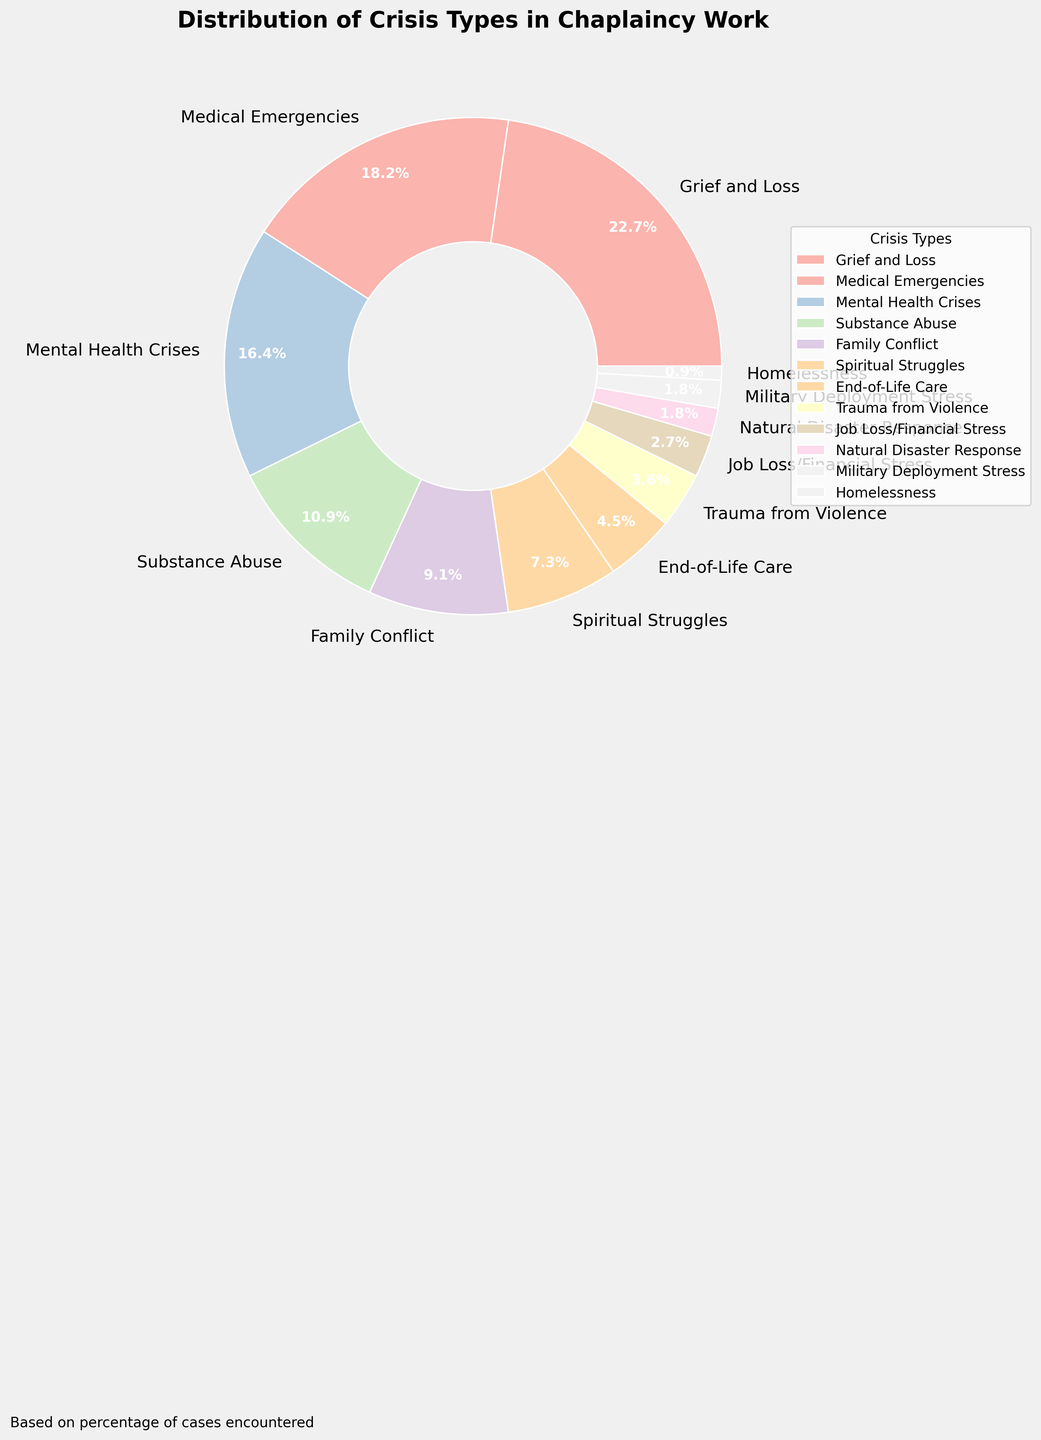What crisis type accounts for the highest percentage? The largest slice in the pie chart represents "Grief and Loss," which accounts for 25% of the total cases.
Answer: Grief and Loss Which crisis type has a lower percentage: "Family Conflict" or "Substance Abuse"? By observing the chart, "Family Conflict" accounts for 10%, while "Substance Abuse" accounts for 12%. Therefore, "Family Conflict" has a lower percentage.
Answer: Family Conflict How do the percentages of "End-of-Life Care" and "Trauma from Violence" combined compare to the percentage of "Mental Health Crises"? "End-of-Life Care" is 5% and "Trauma from Violence" is 4%. Their combined total is 5% + 4% = 9%, which is lower than the 18% of "Mental Health Crises."
Answer: Lower Which crisis type comprises 8% of the cases? The pie chart shows that "Spiritual Struggles" makes up 8% of the cases encountered in chaplaincy work.
Answer: Spiritual Struggles If you combine the percentages of "Job Loss/Financial Stress," "Natural Disaster Response," and "Military Deployment Stress," what is the total percentage? "Job Loss/Financial Stress" is 3%, "Natural Disaster Response" is 2%, and "Military Deployment Stress" is 2%. Adding these together gives 3% + 2% + 2% = 7%.
Answer: 7% Which crisis type has the smallest percentage representation, and what is it? Observing the pie chart, "Homelessness" has the smallest slice, accounting for 1% of the cases.
Answer: Homelessness (1%) What is the difference in percentage between "Grief and Loss" and "Medical Emergencies"? "Grief and Loss" is 25%, and "Medical Emergencies" is 20%. The difference is 25% - 20% = 5%.
Answer: 5% What is the combined percentage of all crisis types that are less than 5% each? The crisis types with percentages less than 5% are "Trauma from Violence" (4%), "Job Loss/Financial Stress" (3%), "Natural Disaster Response" (2%), "Military Deployment Stress" (2%), and "Homelessness" (1%). Adding these: 4% + 3% + 2% + 2% + 1% = 12%.
Answer: 12% What are the percentages of "Medical Emergencies" and "Mental Health Crises" presented visually with the largest and second largest wedges? "Grief and Loss" is the largest at 25%. The second largest wedge is "Medical Emergencies" at 20%, and the third largest is "Mental Health Crises" at 18%.
Answer: Medical Emergencies (20%) and Mental Health Crises (18%) 